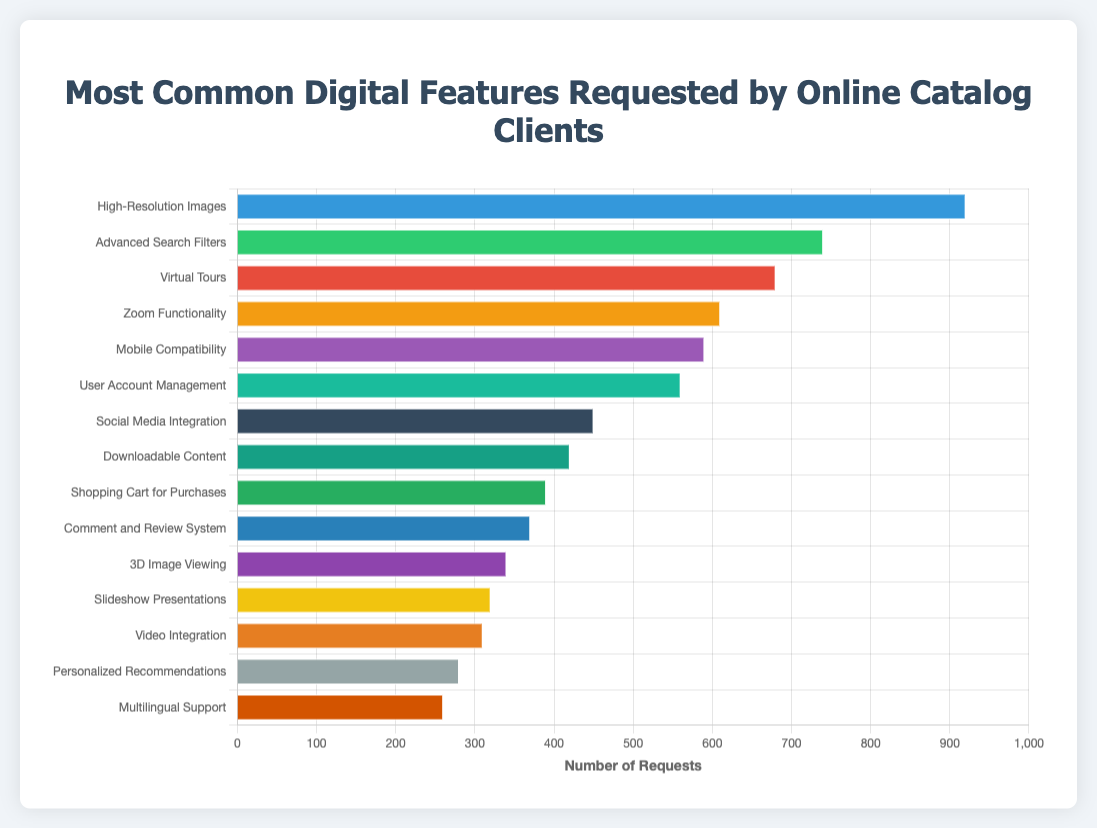Which digital feature has the highest number of requests? The bar representing "High-Resolution Images" is the longest, indicating the highest number of requests at 920.
Answer: High-Resolution Images What are the top three most requested digital features? The three longest bars represent "High-Resolution Images" with 920 requests, "Advanced Search Filters" with 740 requests, and "Virtual Tours" with 680 requests.
Answer: High-Resolution Images, Advanced Search Filters, Virtual Tours How many more requests did "High-Resolution Images" receive compared to "Mobile Compatibility"? Subtract the number of requests for "Mobile Compatibility" (590) from "High-Resolution Images" (920): 920 - 590 = 330.
Answer: 330 Which feature has fewer requests: "Social Media Integration" or "User Account Management"? The bar for "Social Media Integration" (450 requests) is shorter than the bar for "User Account Management" (560 requests).
Answer: Social Media Integration What is the sum of requests for "3D Image Viewing" and "Video Integration"? Add the number of requests for "3D Image Viewing" (340) and "Video Integration" (310): 340 + 310 = 650.
Answer: 650 Which feature received the least number of requests? The shortest bar represents "Multilingual Support" with 260 requests.
Answer: Multilingual Support Are there more requests for "Advanced Search Filters" or "Comment and Review System"? "Advanced Search Filters" received 740 requests, whereas "Comment and Review System" received 370 requests. 740 is greater than 370.
Answer: Advanced Search Filters What is the average number of requests for the bottom five requested features? The bottom five requested features are: "Video Integration" (310), "Personalized Recommendations" (280), "Multilingual Support" (260), "3D Image Viewing" (340), "Slideshow Presentations" (320). Their sum is 310 + 280 + 260 + 340 + 320 = 1510. The average is 1510 / 5 = 302.
Answer: 302 How does the length of the bar for "Zoom Functionality" compare to "Social Media Integration"? The bar for "Zoom Functionality" (610 requests) is longer than the bar for "Social Media Integration" (450 requests).
Answer: Zoom Functionality is longer What is the cumulative total of requests for "Shopping Cart for Purchases" and "Downloadable Content"? Add the number of requests for "Shopping Cart for Purchases" (390) and "Downloadable Content" (420): 390 + 420 = 810.
Answer: 810 